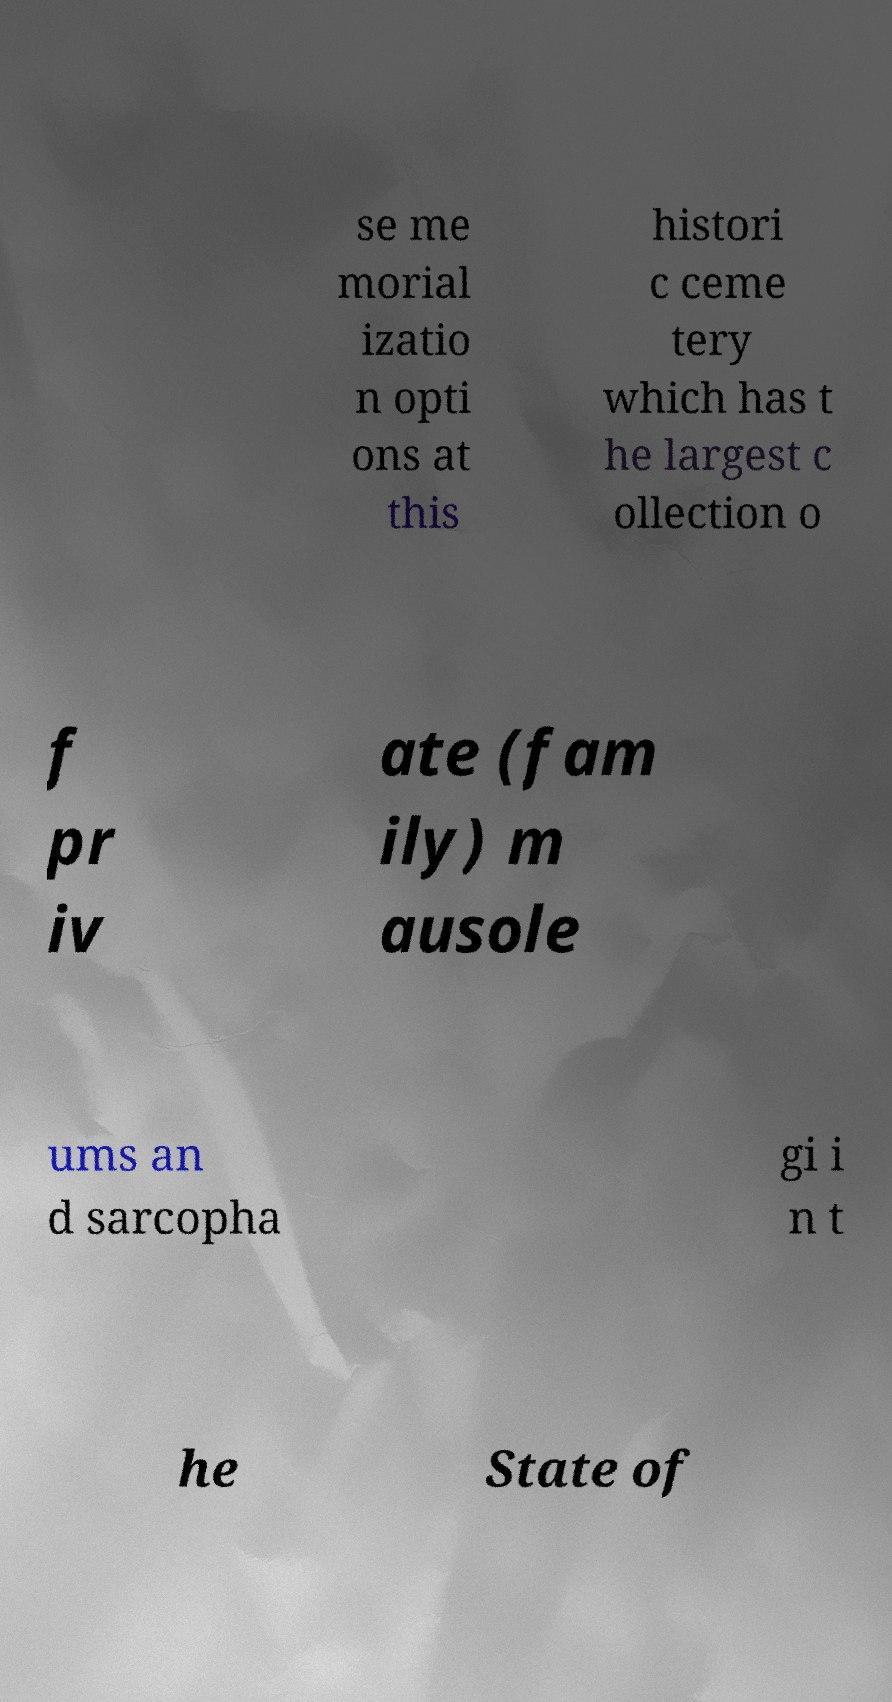Can you read and provide the text displayed in the image?This photo seems to have some interesting text. Can you extract and type it out for me? se me morial izatio n opti ons at this histori c ceme tery which has t he largest c ollection o f pr iv ate (fam ily) m ausole ums an d sarcopha gi i n t he State of 